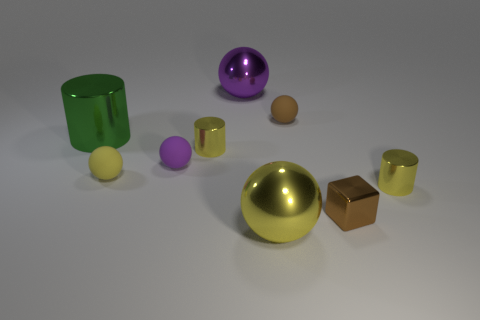Subtract all big yellow metal balls. How many balls are left? 4 Subtract all yellow spheres. How many spheres are left? 3 Subtract 1 cubes. How many cubes are left? 0 Subtract all cylinders. How many objects are left? 6 Subtract all brown cylinders. How many purple spheres are left? 2 Add 6 purple matte objects. How many purple matte objects exist? 7 Subtract 0 red cylinders. How many objects are left? 9 Subtract all red cylinders. Subtract all gray balls. How many cylinders are left? 3 Subtract all tiny red cylinders. Subtract all big purple shiny balls. How many objects are left? 8 Add 5 small yellow cylinders. How many small yellow cylinders are left? 7 